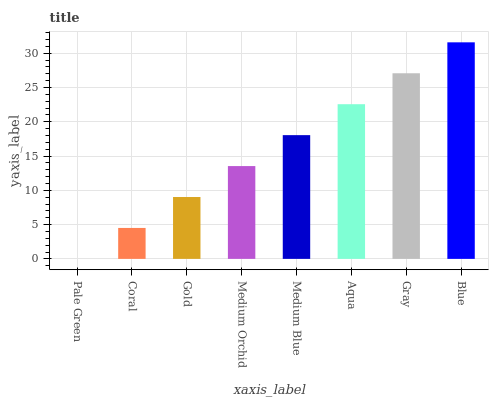Is Pale Green the minimum?
Answer yes or no. Yes. Is Blue the maximum?
Answer yes or no. Yes. Is Coral the minimum?
Answer yes or no. No. Is Coral the maximum?
Answer yes or no. No. Is Coral greater than Pale Green?
Answer yes or no. Yes. Is Pale Green less than Coral?
Answer yes or no. Yes. Is Pale Green greater than Coral?
Answer yes or no. No. Is Coral less than Pale Green?
Answer yes or no. No. Is Medium Blue the high median?
Answer yes or no. Yes. Is Medium Orchid the low median?
Answer yes or no. Yes. Is Gold the high median?
Answer yes or no. No. Is Aqua the low median?
Answer yes or no. No. 